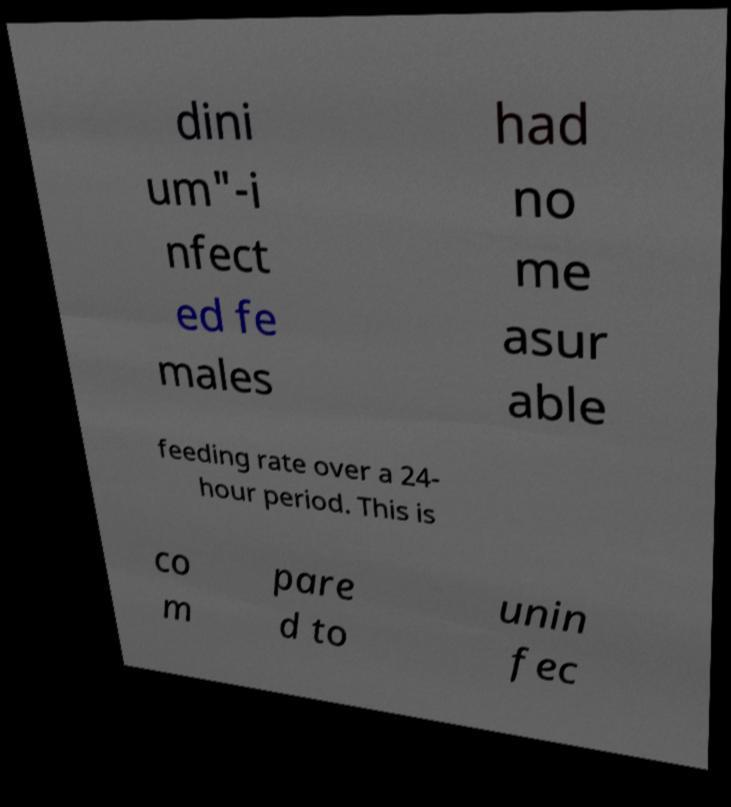I need the written content from this picture converted into text. Can you do that? dini um"-i nfect ed fe males had no me asur able feeding rate over a 24- hour period. This is co m pare d to unin fec 